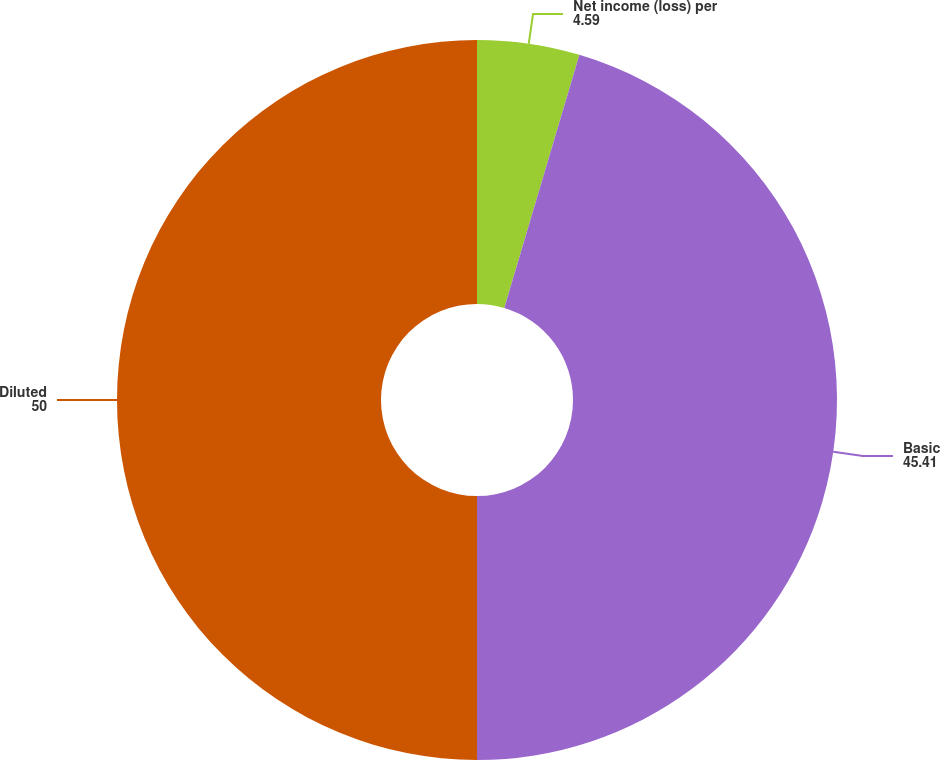<chart> <loc_0><loc_0><loc_500><loc_500><pie_chart><fcel>Net income (loss) per<fcel>Basic<fcel>Diluted<nl><fcel>4.59%<fcel>45.41%<fcel>50.0%<nl></chart> 